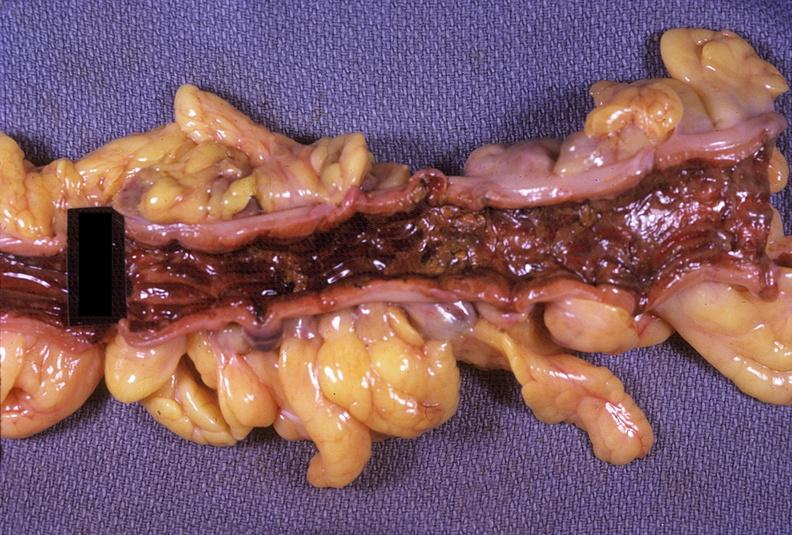what does this image show?
Answer the question using a single word or phrase. Colon 